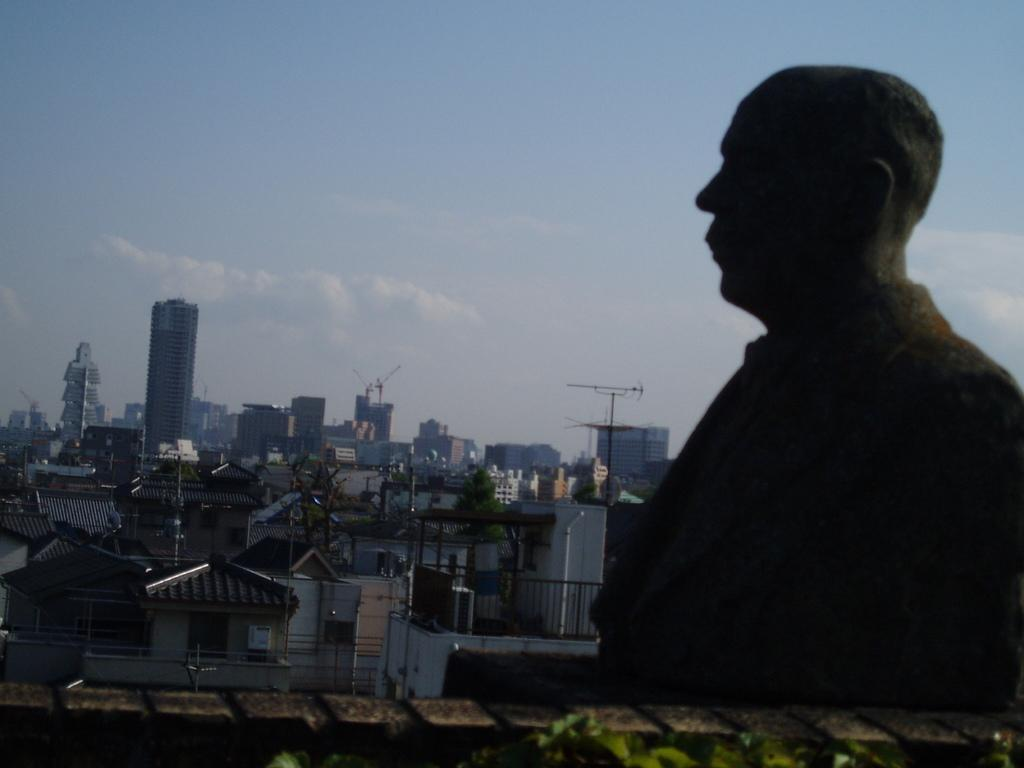What type of structures can be seen in the image? There are buildings in the image. What part of the buildings can be seen in the image? There are windows visible in the image. What architectural feature is present in the image? There is a railing in the image. What else can be seen in the image besides the buildings? There are poles in the image. What is visible in the background of the image? The sky is visible in the image. What is the most prominent object in the foreground of the image? There is a statue in front of the other elements in the image. What direction is the kitty facing in the image? There is no kitty present in the image, so it cannot be determined which direction it might be facing. 